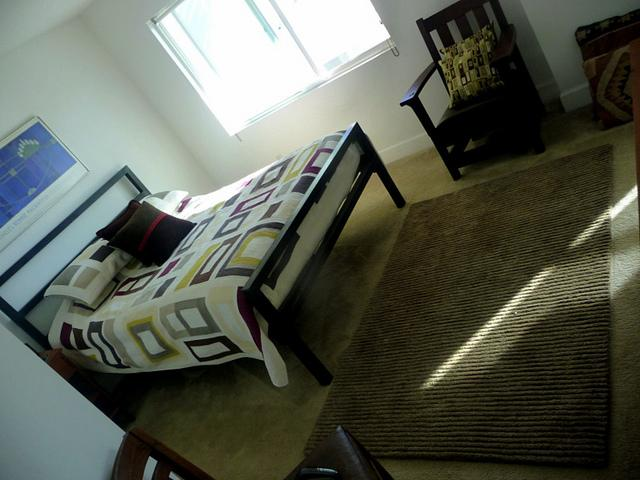What color is the painting on the wall behind the bed stand? Please explain your reasoning. blue. The color matches the sky. 